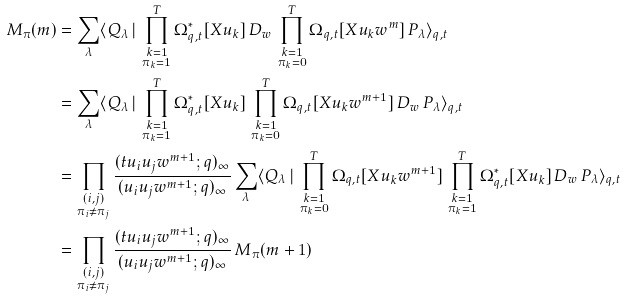Convert formula to latex. <formula><loc_0><loc_0><loc_500><loc_500>M _ { \pi } ( m ) & = \sum _ { \lambda } \langle Q _ { \lambda } \, | \, \prod _ { \substack { k = 1 \\ \pi _ { k } = 1 } } ^ { T } \Omega _ { q , t } ^ { * } [ X u _ { k } ] \, D _ { w } \, \prod _ { \substack { k = 1 \\ \pi _ { k } = 0 } } ^ { T } \Omega _ { q , t } [ X u _ { k } w ^ { m } ] \, P _ { \lambda } \rangle _ { q , t } \\ & = \sum _ { \lambda } \langle Q _ { \lambda } \, | \, \prod _ { \substack { k = 1 \\ \pi _ { k } = 1 } } ^ { T } \Omega _ { q , t } ^ { * } [ X u _ { k } ] \, \prod _ { \substack { k = 1 \\ \pi _ { k } = 0 } } ^ { T } \Omega _ { q , t } [ X u _ { k } w ^ { m + 1 } ] \, D _ { w } \, P _ { \lambda } \rangle _ { q , t } \\ & = \prod _ { \substack { ( i , j ) \\ \pi _ { i } \neq \pi _ { j } } } \frac { ( t u _ { i } u _ { j } w ^ { m + 1 } ; q ) _ { \infty } } { ( u _ { i } u _ { j } w ^ { m + 1 } ; q ) _ { \infty } } \sum _ { \lambda } \langle Q _ { \lambda } \, | \, \prod _ { \substack { k = 1 \\ \pi _ { k } = 0 } } ^ { T } \Omega _ { q , t } [ X u _ { k } w ^ { m + 1 } ] \, \prod _ { \substack { k = 1 \\ \pi _ { k } = 1 } } ^ { T } \Omega _ { q , t } ^ { * } [ X u _ { k } ] \, D _ { w } \, P _ { \lambda } \rangle _ { q , t } \\ & = \prod _ { \substack { ( i , j ) \\ \pi _ { i } \neq \pi _ { j } } } \frac { ( t u _ { i } u _ { j } w ^ { m + 1 } ; q ) _ { \infty } } { ( u _ { i } u _ { j } w ^ { m + 1 } ; q ) _ { \infty } } \, M _ { \pi } ( m + 1 )</formula> 